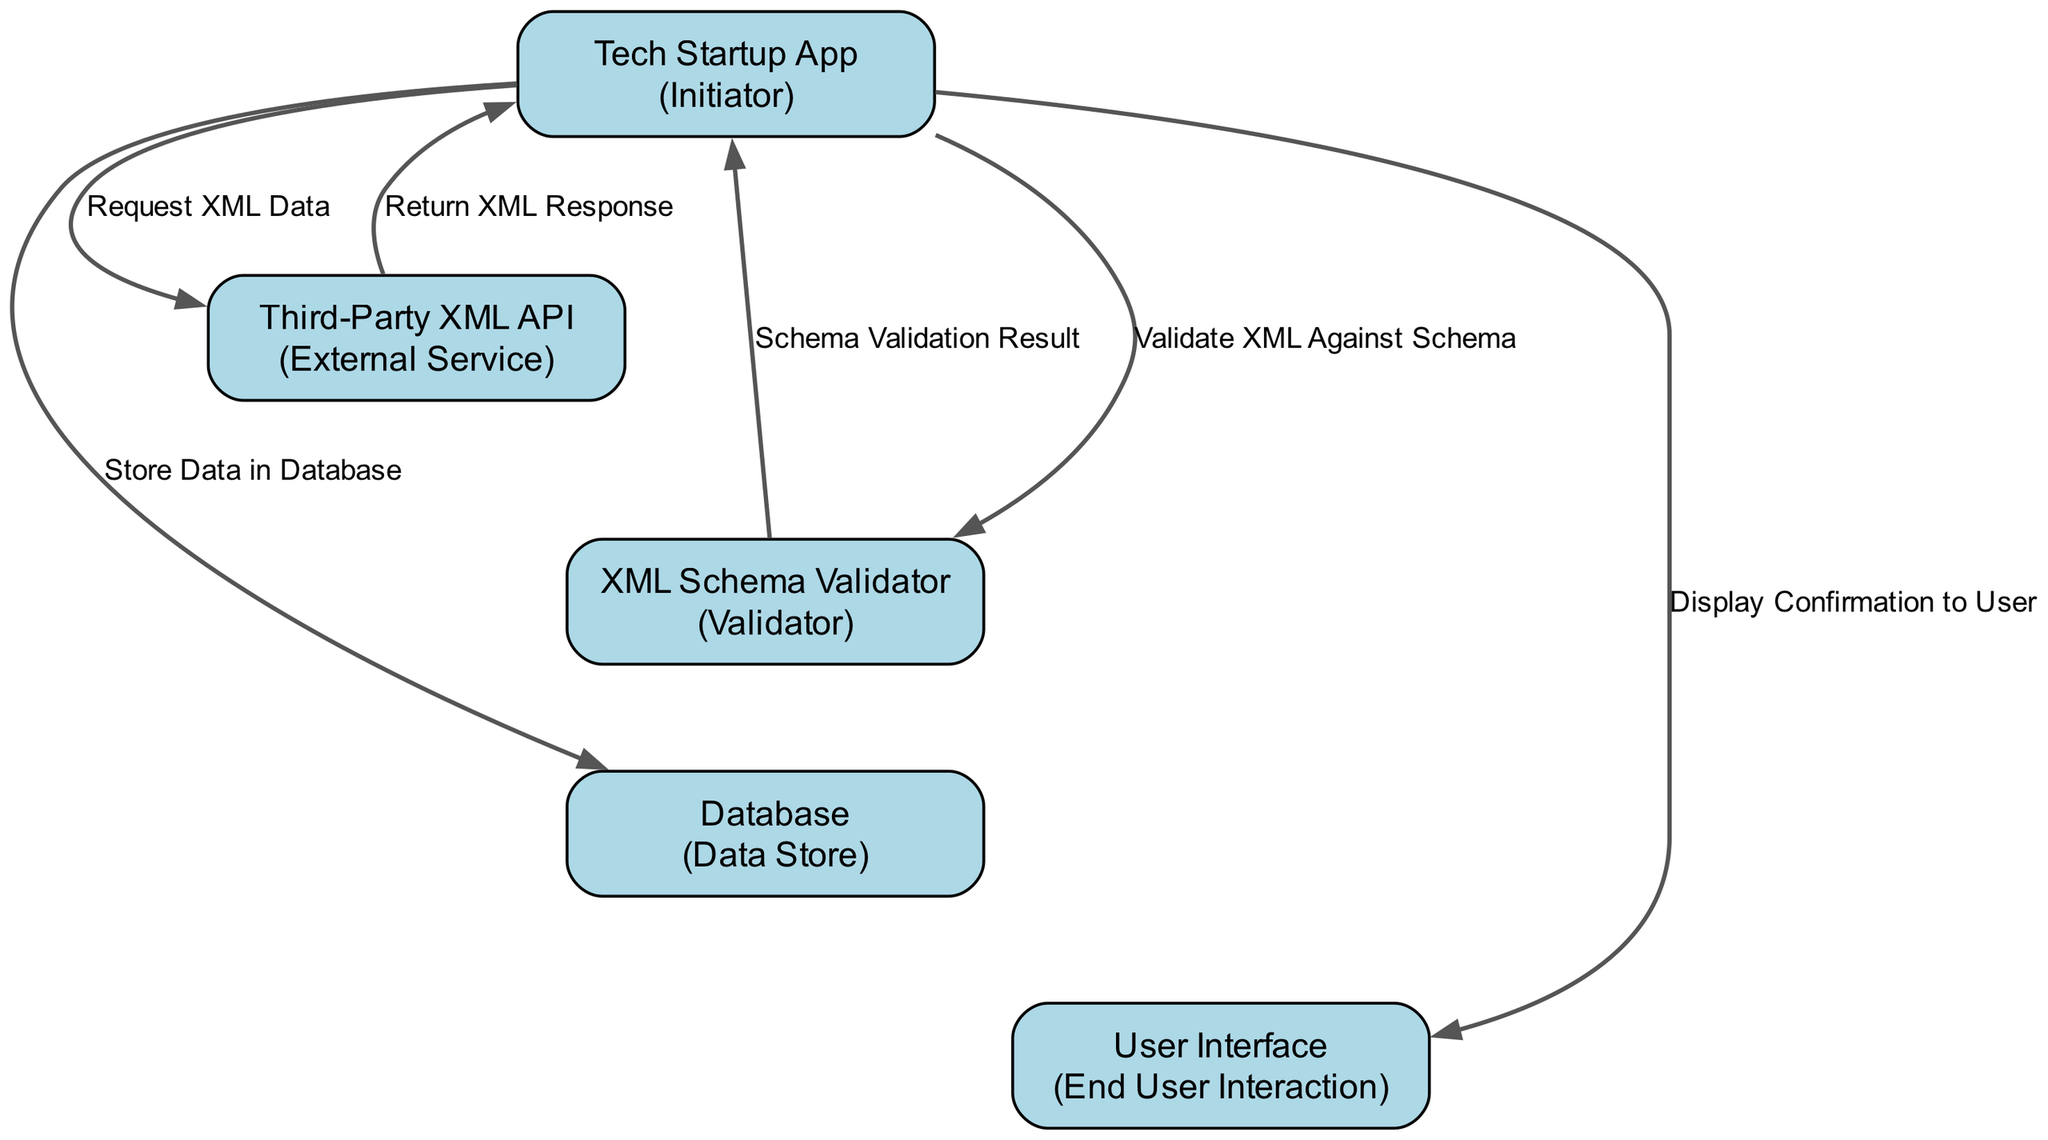What is the first action performed by the Tech Startup App? The first action listed in the diagram is "Request XML Data," which is initiated by the Tech Startup App towards the Third-Party XML API.
Answer: Request XML Data How many participants are there in the sequence diagram? The diagram lists five participants: Tech Startup App, Third-Party XML API, XML Schema Validator, Database, and User Interface.
Answer: Five Which participant validates the XML data? The XML Schema Validator is explicitly mentioned as the participant responsible for validating the XML data against the schema.
Answer: XML Schema Validator What is the last action performed by the Tech Startup App? The last action taken by the Tech Startup App is "Display Confirmation to User," which indicates the final interaction with the user interface.
Answer: Display Confirmation to User What action follows the "Return XML Response"? The action that follows "Return XML Response" is "Validate XML Against Schema," meaning the Tech Startup App validates the response received from the Third-Party XML API.
Answer: Validate XML Against Schema What role does the Database serve in this sequence? The Database serves as the data store where information is stored after validation takes place.
Answer: Data Store How does the Tech Startup App use the XML Schema Validator? The Tech Startup App sends the XML data to the XML Schema Validator for confirmation that it conforms to expected schemas.
Answer: Sends XML data for validation What happens if the XML validation fails? While the diagram does not explicitly show failure actions, typically if validation fails, the system would handle the error (not shown in the diagram).
Answer: Not shown What is the direction of the action "Store Data in Database"? The arrow indicates that the Tech Startup App is sending data to the Database, showing a one-way direction from the app to the database.
Answer: One-way from app to database 